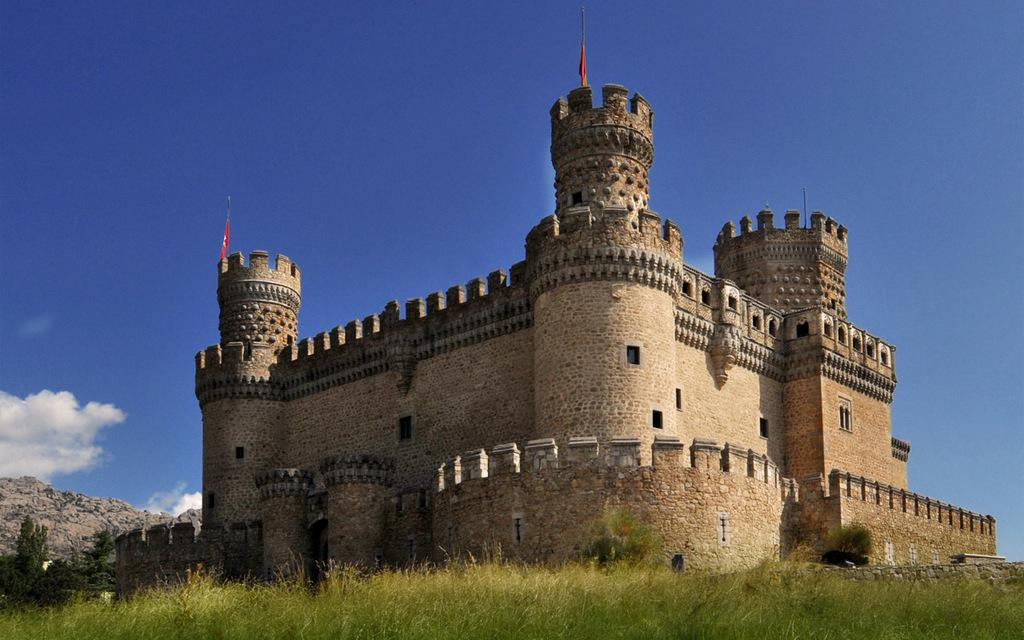What is the main subject in the middle of the picture? There is a monument in the middle of the picture. What type of ground is visible at the bottom of the picture? There is grass on the ground in the bottom of the picture. What can be seen in the background of the picture? The sky is visible in the background of the picture. How many toes can be seen on the monument in the image? There are no toes present on the monument in the image. What type of note is attached to the monument in the image? There is no note attached to the monument in the image. 